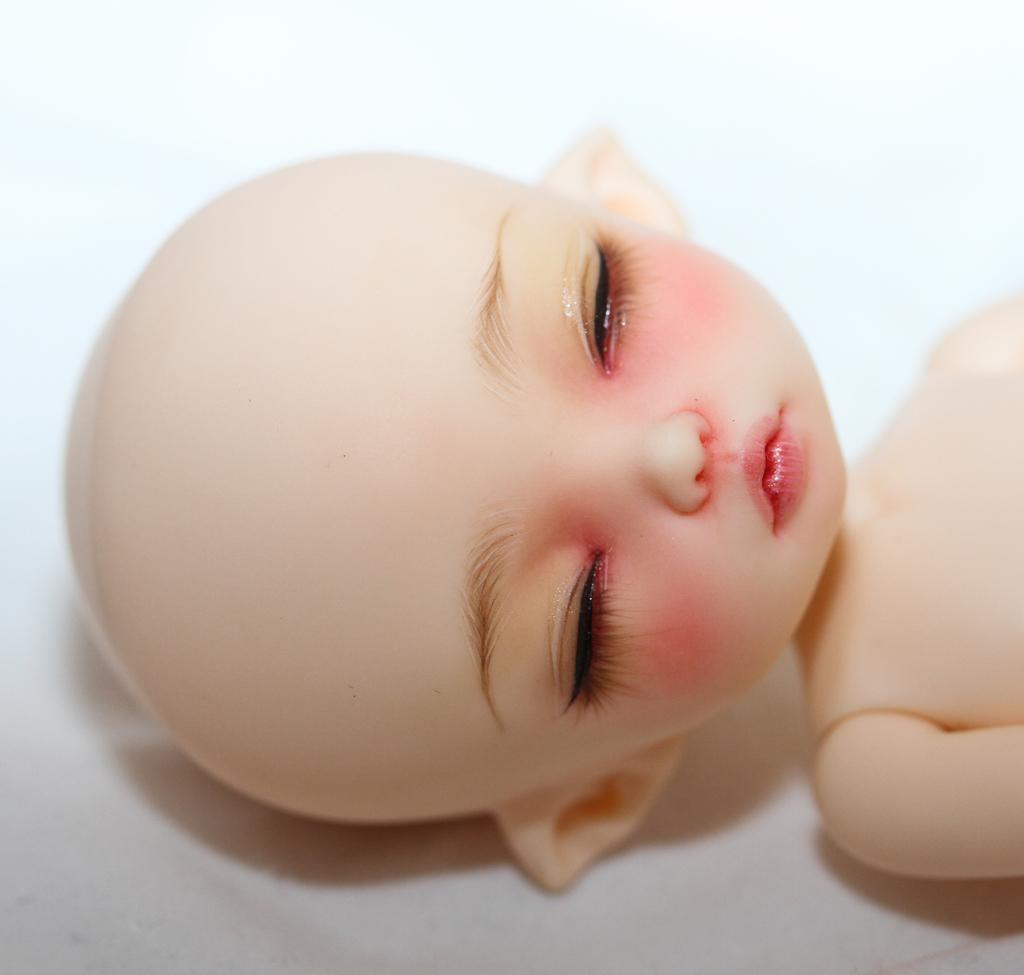Could you give a brief overview of what you see in this image? In this image we can see a doll on the surface. 